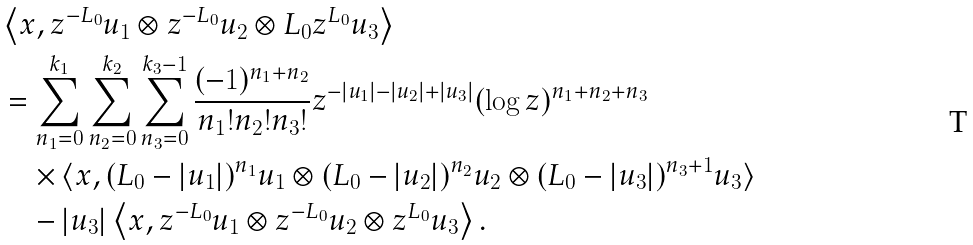<formula> <loc_0><loc_0><loc_500><loc_500>& \left \langle x , z ^ { - L _ { 0 } } u _ { 1 } \otimes z ^ { - L _ { 0 } } u _ { 2 } \otimes L _ { 0 } z ^ { L _ { 0 } } u _ { 3 } \right \rangle \\ & = \sum _ { n _ { 1 } = 0 } ^ { k _ { 1 } } \sum _ { n _ { 2 } = 0 } ^ { k _ { 2 } } \sum _ { n _ { 3 } = 0 } ^ { k _ { 3 } - 1 } \frac { ( - 1 ) ^ { n _ { 1 } + n _ { 2 } } } { n _ { 1 } ! n _ { 2 } ! n _ { 3 } ! } z ^ { - | u _ { 1 } | - | u _ { 2 } | + | u _ { 3 } | } ( \log z ) ^ { n _ { 1 } + n _ { 2 } + n _ { 3 } } \\ & \quad \times \langle x , ( L _ { 0 } - | u _ { 1 } | ) ^ { n _ { 1 } } u _ { 1 } \otimes ( L _ { 0 } - | u _ { 2 } | ) ^ { n _ { 2 } } u _ { 2 } \otimes ( L _ { 0 } - | u _ { 3 } | ) ^ { n _ { 3 } + 1 } u _ { 3 } \rangle \\ & \quad - | u _ { 3 } | \left \langle x , z ^ { - L _ { 0 } } u _ { 1 } \otimes z ^ { - L _ { 0 } } u _ { 2 } \otimes z ^ { L _ { 0 } } u _ { 3 } \right \rangle .</formula> 